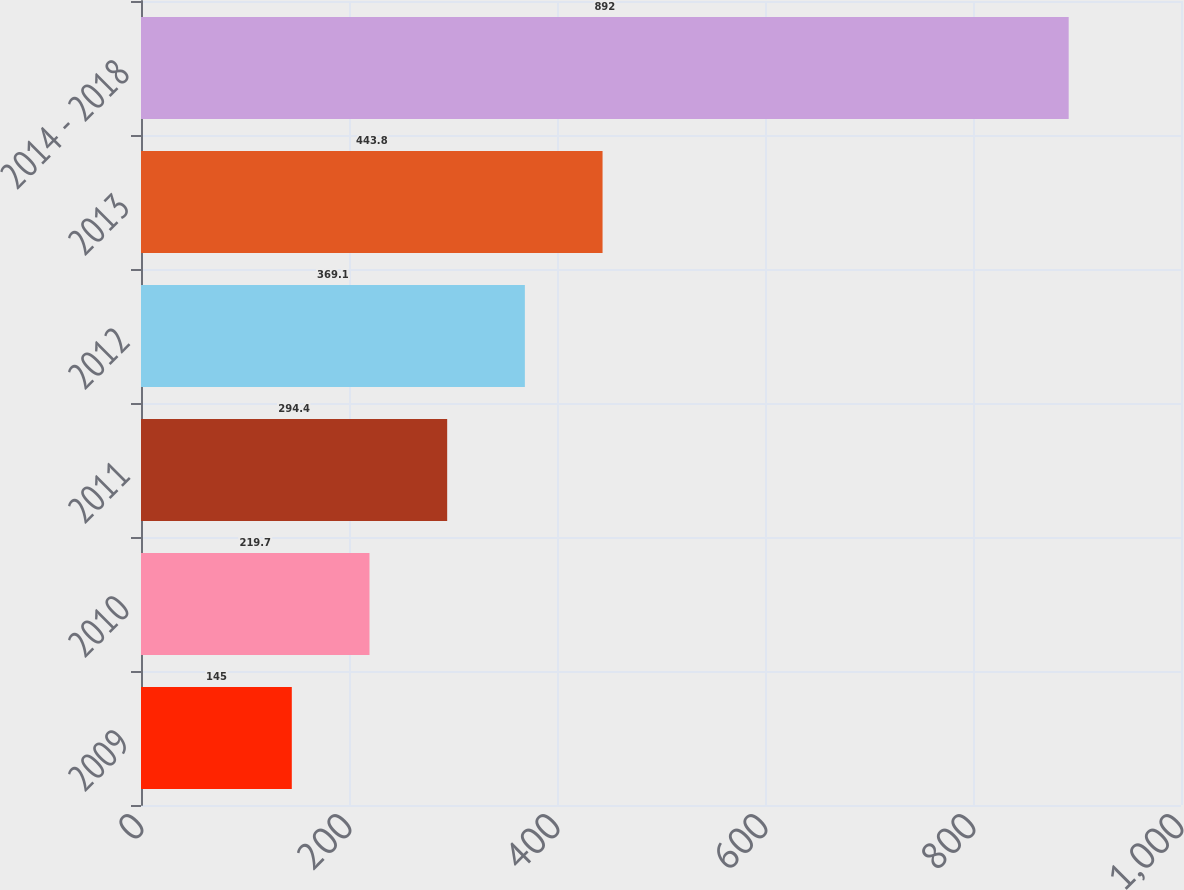Convert chart. <chart><loc_0><loc_0><loc_500><loc_500><bar_chart><fcel>2009<fcel>2010<fcel>2011<fcel>2012<fcel>2013<fcel>2014 - 2018<nl><fcel>145<fcel>219.7<fcel>294.4<fcel>369.1<fcel>443.8<fcel>892<nl></chart> 